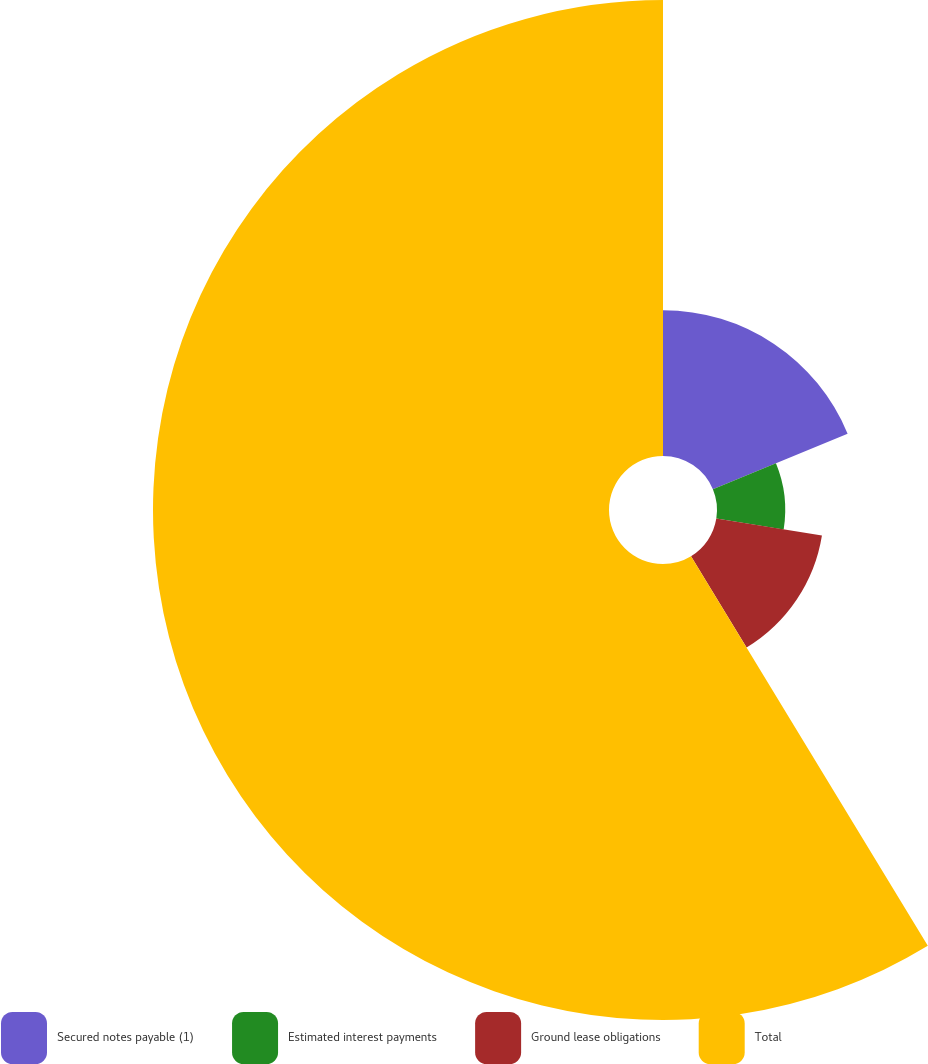<chart> <loc_0><loc_0><loc_500><loc_500><pie_chart><fcel>Secured notes payable (1)<fcel>Estimated interest payments<fcel>Ground lease obligations<fcel>Total<nl><fcel>18.76%<fcel>8.78%<fcel>13.77%<fcel>58.69%<nl></chart> 